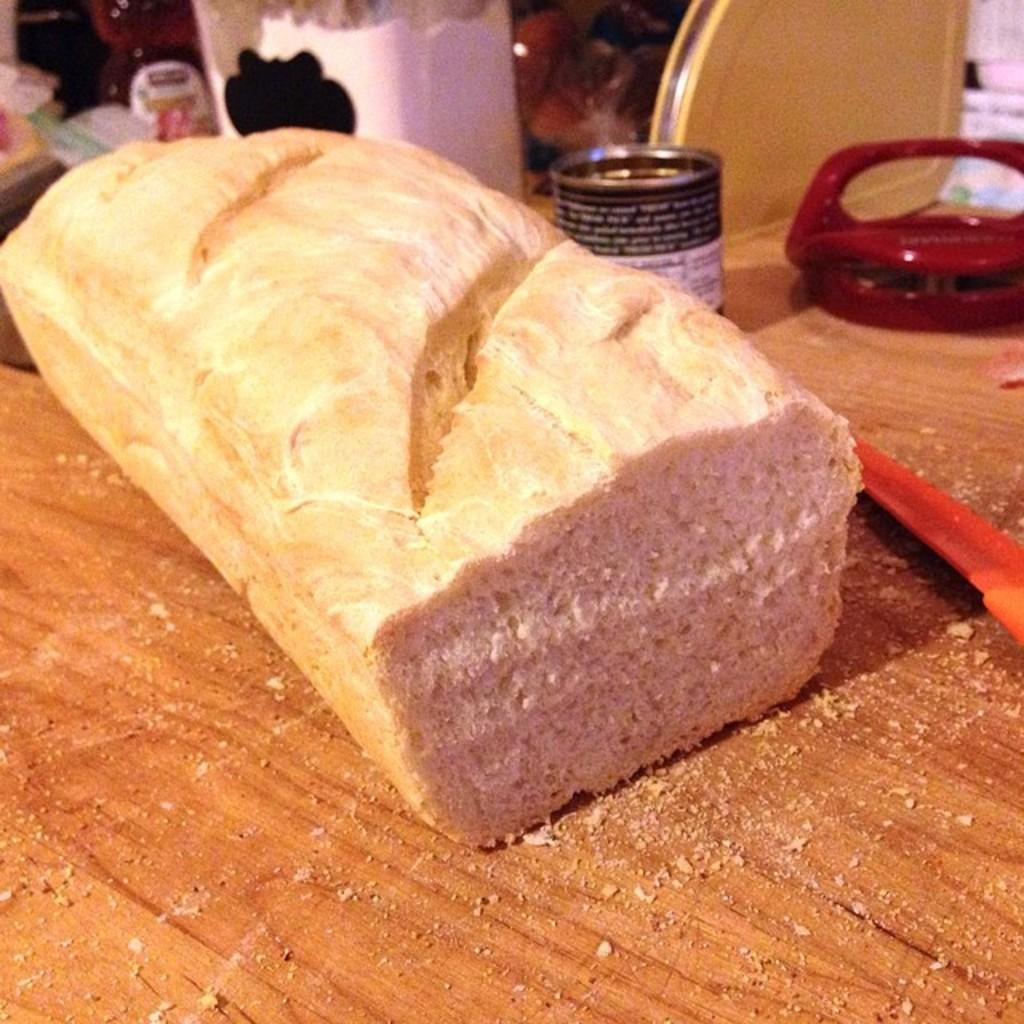How would you summarize this image in a sentence or two? In this picture I can observe food placed on the table. On the right side there is a tin. In the background there are few other things on the table. 